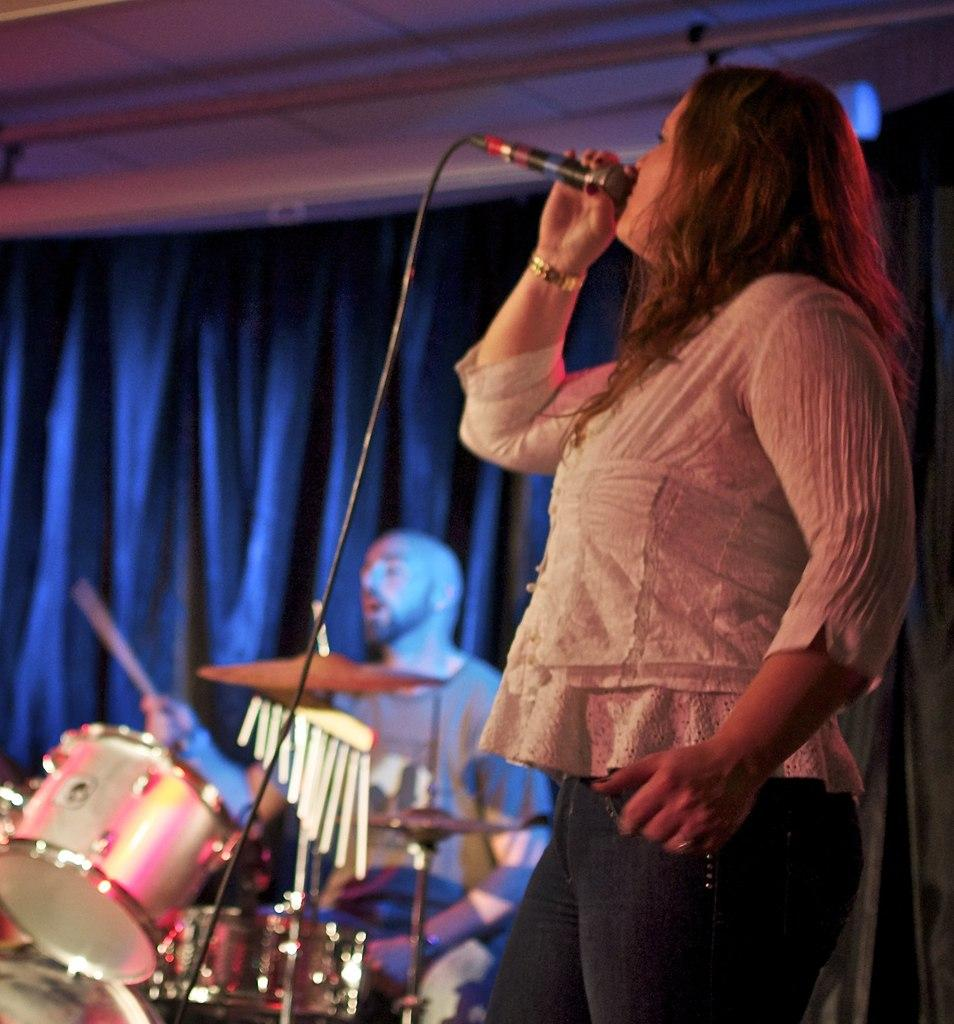What is the person on the left side of the image doing? The person on the left side of the image is holding a microphone. What is the person on the right side of the image doing? The person on the right side of the image is playing a musical instrument. What can be seen in the background of the image? There is a curtain in the image. What architectural feature is present in the image? There is a pole attached to the roof in the image. What type of discovery is being made on the tray in the image? There is no tray present in the image, and therefore no discovery can be observed. 